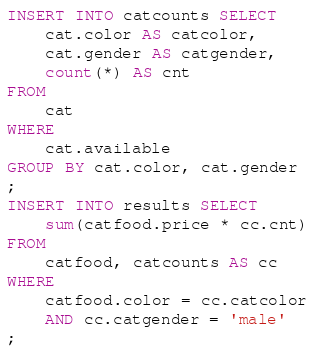Convert code to text. <code><loc_0><loc_0><loc_500><loc_500><_SQL_>INSERT INTO catcounts SELECT
    cat.color AS catcolor,
    cat.gender AS catgender,
    count(*) AS cnt
FROM
    cat
WHERE
    cat.available
GROUP BY cat.color, cat.gender
;
INSERT INTO results SELECT
    sum(catfood.price * cc.cnt)
FROM
    catfood, catcounts AS cc
WHERE
    catfood.color = cc.catcolor
    AND cc.catgender = 'male'
;
</code> 